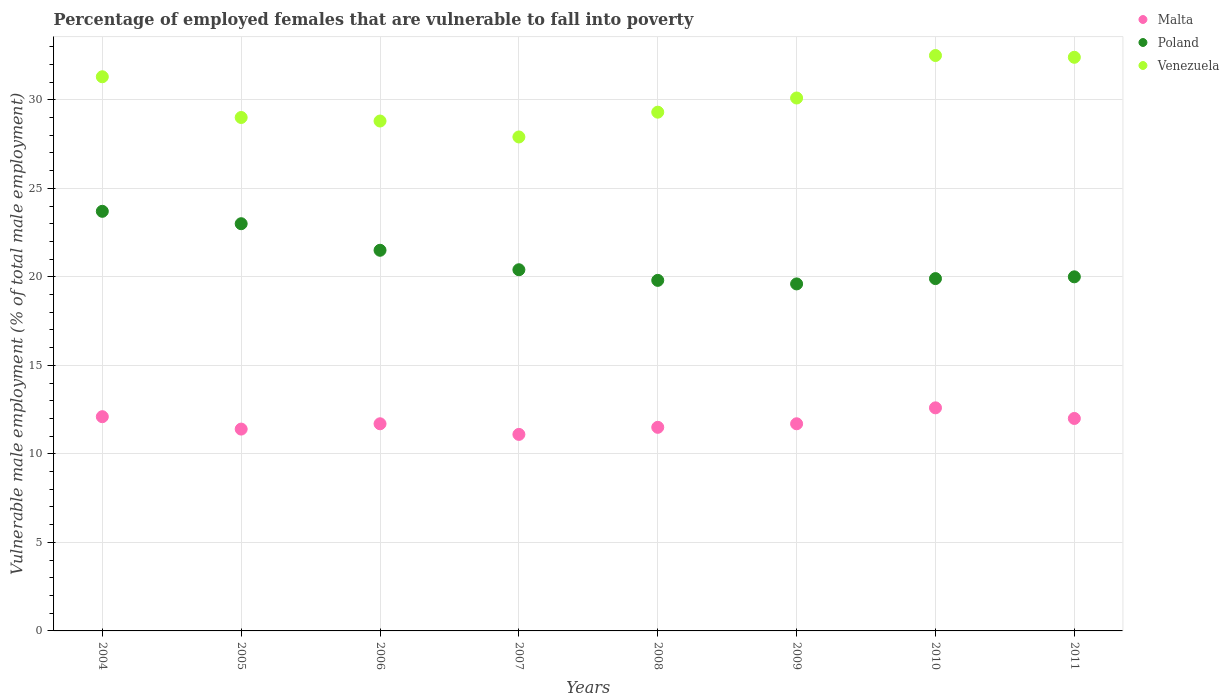Is the number of dotlines equal to the number of legend labels?
Your answer should be compact. Yes. What is the percentage of employed females who are vulnerable to fall into poverty in Venezuela in 2010?
Offer a terse response. 32.5. Across all years, what is the maximum percentage of employed females who are vulnerable to fall into poverty in Poland?
Give a very brief answer. 23.7. Across all years, what is the minimum percentage of employed females who are vulnerable to fall into poverty in Poland?
Offer a terse response. 19.6. In which year was the percentage of employed females who are vulnerable to fall into poverty in Malta maximum?
Provide a succinct answer. 2010. What is the total percentage of employed females who are vulnerable to fall into poverty in Poland in the graph?
Keep it short and to the point. 167.9. What is the difference between the percentage of employed females who are vulnerable to fall into poverty in Venezuela in 2006 and that in 2010?
Offer a terse response. -3.7. What is the difference between the percentage of employed females who are vulnerable to fall into poverty in Poland in 2009 and the percentage of employed females who are vulnerable to fall into poverty in Malta in 2007?
Provide a succinct answer. 8.5. What is the average percentage of employed females who are vulnerable to fall into poverty in Venezuela per year?
Your answer should be very brief. 30.16. In the year 2004, what is the difference between the percentage of employed females who are vulnerable to fall into poverty in Venezuela and percentage of employed females who are vulnerable to fall into poverty in Malta?
Offer a very short reply. 19.2. What is the ratio of the percentage of employed females who are vulnerable to fall into poverty in Poland in 2005 to that in 2007?
Offer a terse response. 1.13. Is the difference between the percentage of employed females who are vulnerable to fall into poverty in Venezuela in 2008 and 2010 greater than the difference between the percentage of employed females who are vulnerable to fall into poverty in Malta in 2008 and 2010?
Provide a short and direct response. No. What is the difference between the highest and the lowest percentage of employed females who are vulnerable to fall into poverty in Poland?
Give a very brief answer. 4.1. Is it the case that in every year, the sum of the percentage of employed females who are vulnerable to fall into poverty in Malta and percentage of employed females who are vulnerable to fall into poverty in Venezuela  is greater than the percentage of employed females who are vulnerable to fall into poverty in Poland?
Ensure brevity in your answer.  Yes. Is the percentage of employed females who are vulnerable to fall into poverty in Malta strictly greater than the percentage of employed females who are vulnerable to fall into poverty in Venezuela over the years?
Provide a short and direct response. No. Is the percentage of employed females who are vulnerable to fall into poverty in Malta strictly less than the percentage of employed females who are vulnerable to fall into poverty in Poland over the years?
Your answer should be very brief. Yes. How many years are there in the graph?
Ensure brevity in your answer.  8. What is the difference between two consecutive major ticks on the Y-axis?
Make the answer very short. 5. Does the graph contain any zero values?
Give a very brief answer. No. What is the title of the graph?
Offer a very short reply. Percentage of employed females that are vulnerable to fall into poverty. What is the label or title of the X-axis?
Offer a very short reply. Years. What is the label or title of the Y-axis?
Provide a short and direct response. Vulnerable male employment (% of total male employment). What is the Vulnerable male employment (% of total male employment) of Malta in 2004?
Provide a succinct answer. 12.1. What is the Vulnerable male employment (% of total male employment) of Poland in 2004?
Provide a short and direct response. 23.7. What is the Vulnerable male employment (% of total male employment) of Venezuela in 2004?
Make the answer very short. 31.3. What is the Vulnerable male employment (% of total male employment) of Malta in 2005?
Provide a succinct answer. 11.4. What is the Vulnerable male employment (% of total male employment) in Malta in 2006?
Ensure brevity in your answer.  11.7. What is the Vulnerable male employment (% of total male employment) of Venezuela in 2006?
Give a very brief answer. 28.8. What is the Vulnerable male employment (% of total male employment) in Malta in 2007?
Make the answer very short. 11.1. What is the Vulnerable male employment (% of total male employment) in Poland in 2007?
Provide a succinct answer. 20.4. What is the Vulnerable male employment (% of total male employment) of Venezuela in 2007?
Your answer should be very brief. 27.9. What is the Vulnerable male employment (% of total male employment) of Poland in 2008?
Your response must be concise. 19.8. What is the Vulnerable male employment (% of total male employment) of Venezuela in 2008?
Keep it short and to the point. 29.3. What is the Vulnerable male employment (% of total male employment) in Malta in 2009?
Your response must be concise. 11.7. What is the Vulnerable male employment (% of total male employment) in Poland in 2009?
Offer a terse response. 19.6. What is the Vulnerable male employment (% of total male employment) in Venezuela in 2009?
Your answer should be compact. 30.1. What is the Vulnerable male employment (% of total male employment) in Malta in 2010?
Your response must be concise. 12.6. What is the Vulnerable male employment (% of total male employment) in Poland in 2010?
Your answer should be very brief. 19.9. What is the Vulnerable male employment (% of total male employment) of Venezuela in 2010?
Ensure brevity in your answer.  32.5. What is the Vulnerable male employment (% of total male employment) in Poland in 2011?
Make the answer very short. 20. What is the Vulnerable male employment (% of total male employment) in Venezuela in 2011?
Ensure brevity in your answer.  32.4. Across all years, what is the maximum Vulnerable male employment (% of total male employment) in Malta?
Your answer should be compact. 12.6. Across all years, what is the maximum Vulnerable male employment (% of total male employment) of Poland?
Offer a terse response. 23.7. Across all years, what is the maximum Vulnerable male employment (% of total male employment) of Venezuela?
Offer a terse response. 32.5. Across all years, what is the minimum Vulnerable male employment (% of total male employment) in Malta?
Offer a terse response. 11.1. Across all years, what is the minimum Vulnerable male employment (% of total male employment) of Poland?
Provide a short and direct response. 19.6. Across all years, what is the minimum Vulnerable male employment (% of total male employment) in Venezuela?
Your response must be concise. 27.9. What is the total Vulnerable male employment (% of total male employment) of Malta in the graph?
Make the answer very short. 94.1. What is the total Vulnerable male employment (% of total male employment) in Poland in the graph?
Give a very brief answer. 167.9. What is the total Vulnerable male employment (% of total male employment) of Venezuela in the graph?
Your answer should be very brief. 241.3. What is the difference between the Vulnerable male employment (% of total male employment) of Malta in 2004 and that in 2005?
Offer a terse response. 0.7. What is the difference between the Vulnerable male employment (% of total male employment) of Poland in 2004 and that in 2006?
Ensure brevity in your answer.  2.2. What is the difference between the Vulnerable male employment (% of total male employment) in Venezuela in 2004 and that in 2006?
Ensure brevity in your answer.  2.5. What is the difference between the Vulnerable male employment (% of total male employment) of Poland in 2004 and that in 2007?
Make the answer very short. 3.3. What is the difference between the Vulnerable male employment (% of total male employment) in Malta in 2004 and that in 2009?
Offer a terse response. 0.4. What is the difference between the Vulnerable male employment (% of total male employment) of Poland in 2004 and that in 2009?
Your answer should be compact. 4.1. What is the difference between the Vulnerable male employment (% of total male employment) in Malta in 2004 and that in 2010?
Offer a terse response. -0.5. What is the difference between the Vulnerable male employment (% of total male employment) of Malta in 2004 and that in 2011?
Make the answer very short. 0.1. What is the difference between the Vulnerable male employment (% of total male employment) in Poland in 2004 and that in 2011?
Ensure brevity in your answer.  3.7. What is the difference between the Vulnerable male employment (% of total male employment) in Malta in 2005 and that in 2006?
Your answer should be compact. -0.3. What is the difference between the Vulnerable male employment (% of total male employment) of Venezuela in 2005 and that in 2006?
Make the answer very short. 0.2. What is the difference between the Vulnerable male employment (% of total male employment) in Venezuela in 2005 and that in 2007?
Keep it short and to the point. 1.1. What is the difference between the Vulnerable male employment (% of total male employment) in Poland in 2005 and that in 2008?
Provide a short and direct response. 3.2. What is the difference between the Vulnerable male employment (% of total male employment) in Malta in 2005 and that in 2009?
Give a very brief answer. -0.3. What is the difference between the Vulnerable male employment (% of total male employment) of Poland in 2005 and that in 2009?
Your answer should be very brief. 3.4. What is the difference between the Vulnerable male employment (% of total male employment) in Venezuela in 2005 and that in 2009?
Give a very brief answer. -1.1. What is the difference between the Vulnerable male employment (% of total male employment) in Malta in 2005 and that in 2011?
Offer a terse response. -0.6. What is the difference between the Vulnerable male employment (% of total male employment) in Poland in 2005 and that in 2011?
Provide a succinct answer. 3. What is the difference between the Vulnerable male employment (% of total male employment) of Venezuela in 2005 and that in 2011?
Your response must be concise. -3.4. What is the difference between the Vulnerable male employment (% of total male employment) in Poland in 2006 and that in 2007?
Offer a terse response. 1.1. What is the difference between the Vulnerable male employment (% of total male employment) in Malta in 2006 and that in 2008?
Provide a short and direct response. 0.2. What is the difference between the Vulnerable male employment (% of total male employment) in Malta in 2006 and that in 2009?
Your response must be concise. 0. What is the difference between the Vulnerable male employment (% of total male employment) of Poland in 2006 and that in 2010?
Ensure brevity in your answer.  1.6. What is the difference between the Vulnerable male employment (% of total male employment) of Venezuela in 2006 and that in 2010?
Your answer should be very brief. -3.7. What is the difference between the Vulnerable male employment (% of total male employment) in Malta in 2006 and that in 2011?
Make the answer very short. -0.3. What is the difference between the Vulnerable male employment (% of total male employment) of Poland in 2006 and that in 2011?
Provide a succinct answer. 1.5. What is the difference between the Vulnerable male employment (% of total male employment) in Venezuela in 2006 and that in 2011?
Your answer should be very brief. -3.6. What is the difference between the Vulnerable male employment (% of total male employment) in Poland in 2007 and that in 2008?
Offer a terse response. 0.6. What is the difference between the Vulnerable male employment (% of total male employment) in Venezuela in 2007 and that in 2008?
Keep it short and to the point. -1.4. What is the difference between the Vulnerable male employment (% of total male employment) of Venezuela in 2007 and that in 2009?
Your answer should be compact. -2.2. What is the difference between the Vulnerable male employment (% of total male employment) in Malta in 2007 and that in 2010?
Provide a short and direct response. -1.5. What is the difference between the Vulnerable male employment (% of total male employment) in Malta in 2007 and that in 2011?
Make the answer very short. -0.9. What is the difference between the Vulnerable male employment (% of total male employment) in Poland in 2007 and that in 2011?
Ensure brevity in your answer.  0.4. What is the difference between the Vulnerable male employment (% of total male employment) of Venezuela in 2007 and that in 2011?
Ensure brevity in your answer.  -4.5. What is the difference between the Vulnerable male employment (% of total male employment) in Malta in 2008 and that in 2009?
Keep it short and to the point. -0.2. What is the difference between the Vulnerable male employment (% of total male employment) of Poland in 2008 and that in 2009?
Your answer should be compact. 0.2. What is the difference between the Vulnerable male employment (% of total male employment) in Malta in 2008 and that in 2010?
Your answer should be compact. -1.1. What is the difference between the Vulnerable male employment (% of total male employment) in Poland in 2008 and that in 2010?
Give a very brief answer. -0.1. What is the difference between the Vulnerable male employment (% of total male employment) of Venezuela in 2008 and that in 2010?
Offer a very short reply. -3.2. What is the difference between the Vulnerable male employment (% of total male employment) in Malta in 2008 and that in 2011?
Your answer should be very brief. -0.5. What is the difference between the Vulnerable male employment (% of total male employment) of Venezuela in 2008 and that in 2011?
Your answer should be compact. -3.1. What is the difference between the Vulnerable male employment (% of total male employment) in Malta in 2009 and that in 2010?
Ensure brevity in your answer.  -0.9. What is the difference between the Vulnerable male employment (% of total male employment) in Malta in 2009 and that in 2011?
Make the answer very short. -0.3. What is the difference between the Vulnerable male employment (% of total male employment) of Poland in 2009 and that in 2011?
Provide a succinct answer. -0.4. What is the difference between the Vulnerable male employment (% of total male employment) of Venezuela in 2009 and that in 2011?
Your answer should be compact. -2.3. What is the difference between the Vulnerable male employment (% of total male employment) of Poland in 2010 and that in 2011?
Make the answer very short. -0.1. What is the difference between the Vulnerable male employment (% of total male employment) in Malta in 2004 and the Vulnerable male employment (% of total male employment) in Venezuela in 2005?
Keep it short and to the point. -16.9. What is the difference between the Vulnerable male employment (% of total male employment) in Poland in 2004 and the Vulnerable male employment (% of total male employment) in Venezuela in 2005?
Keep it short and to the point. -5.3. What is the difference between the Vulnerable male employment (% of total male employment) in Malta in 2004 and the Vulnerable male employment (% of total male employment) in Venezuela in 2006?
Your answer should be compact. -16.7. What is the difference between the Vulnerable male employment (% of total male employment) in Poland in 2004 and the Vulnerable male employment (% of total male employment) in Venezuela in 2006?
Your answer should be compact. -5.1. What is the difference between the Vulnerable male employment (% of total male employment) in Malta in 2004 and the Vulnerable male employment (% of total male employment) in Venezuela in 2007?
Offer a very short reply. -15.8. What is the difference between the Vulnerable male employment (% of total male employment) of Malta in 2004 and the Vulnerable male employment (% of total male employment) of Venezuela in 2008?
Provide a short and direct response. -17.2. What is the difference between the Vulnerable male employment (% of total male employment) of Poland in 2004 and the Vulnerable male employment (% of total male employment) of Venezuela in 2008?
Keep it short and to the point. -5.6. What is the difference between the Vulnerable male employment (% of total male employment) of Malta in 2004 and the Vulnerable male employment (% of total male employment) of Poland in 2009?
Provide a short and direct response. -7.5. What is the difference between the Vulnerable male employment (% of total male employment) of Malta in 2004 and the Vulnerable male employment (% of total male employment) of Venezuela in 2009?
Offer a very short reply. -18. What is the difference between the Vulnerable male employment (% of total male employment) in Malta in 2004 and the Vulnerable male employment (% of total male employment) in Poland in 2010?
Your answer should be compact. -7.8. What is the difference between the Vulnerable male employment (% of total male employment) of Malta in 2004 and the Vulnerable male employment (% of total male employment) of Venezuela in 2010?
Make the answer very short. -20.4. What is the difference between the Vulnerable male employment (% of total male employment) of Poland in 2004 and the Vulnerable male employment (% of total male employment) of Venezuela in 2010?
Ensure brevity in your answer.  -8.8. What is the difference between the Vulnerable male employment (% of total male employment) in Malta in 2004 and the Vulnerable male employment (% of total male employment) in Poland in 2011?
Ensure brevity in your answer.  -7.9. What is the difference between the Vulnerable male employment (% of total male employment) in Malta in 2004 and the Vulnerable male employment (% of total male employment) in Venezuela in 2011?
Provide a succinct answer. -20.3. What is the difference between the Vulnerable male employment (% of total male employment) in Poland in 2004 and the Vulnerable male employment (% of total male employment) in Venezuela in 2011?
Give a very brief answer. -8.7. What is the difference between the Vulnerable male employment (% of total male employment) in Malta in 2005 and the Vulnerable male employment (% of total male employment) in Venezuela in 2006?
Keep it short and to the point. -17.4. What is the difference between the Vulnerable male employment (% of total male employment) of Poland in 2005 and the Vulnerable male employment (% of total male employment) of Venezuela in 2006?
Provide a succinct answer. -5.8. What is the difference between the Vulnerable male employment (% of total male employment) in Malta in 2005 and the Vulnerable male employment (% of total male employment) in Venezuela in 2007?
Provide a short and direct response. -16.5. What is the difference between the Vulnerable male employment (% of total male employment) of Malta in 2005 and the Vulnerable male employment (% of total male employment) of Venezuela in 2008?
Your answer should be very brief. -17.9. What is the difference between the Vulnerable male employment (% of total male employment) in Poland in 2005 and the Vulnerable male employment (% of total male employment) in Venezuela in 2008?
Your response must be concise. -6.3. What is the difference between the Vulnerable male employment (% of total male employment) in Malta in 2005 and the Vulnerable male employment (% of total male employment) in Venezuela in 2009?
Offer a very short reply. -18.7. What is the difference between the Vulnerable male employment (% of total male employment) in Poland in 2005 and the Vulnerable male employment (% of total male employment) in Venezuela in 2009?
Offer a very short reply. -7.1. What is the difference between the Vulnerable male employment (% of total male employment) of Malta in 2005 and the Vulnerable male employment (% of total male employment) of Poland in 2010?
Your answer should be compact. -8.5. What is the difference between the Vulnerable male employment (% of total male employment) of Malta in 2005 and the Vulnerable male employment (% of total male employment) of Venezuela in 2010?
Provide a short and direct response. -21.1. What is the difference between the Vulnerable male employment (% of total male employment) in Poland in 2005 and the Vulnerable male employment (% of total male employment) in Venezuela in 2010?
Your answer should be very brief. -9.5. What is the difference between the Vulnerable male employment (% of total male employment) in Malta in 2005 and the Vulnerable male employment (% of total male employment) in Venezuela in 2011?
Provide a short and direct response. -21. What is the difference between the Vulnerable male employment (% of total male employment) of Malta in 2006 and the Vulnerable male employment (% of total male employment) of Venezuela in 2007?
Offer a terse response. -16.2. What is the difference between the Vulnerable male employment (% of total male employment) in Malta in 2006 and the Vulnerable male employment (% of total male employment) in Poland in 2008?
Provide a short and direct response. -8.1. What is the difference between the Vulnerable male employment (% of total male employment) in Malta in 2006 and the Vulnerable male employment (% of total male employment) in Venezuela in 2008?
Ensure brevity in your answer.  -17.6. What is the difference between the Vulnerable male employment (% of total male employment) of Malta in 2006 and the Vulnerable male employment (% of total male employment) of Poland in 2009?
Provide a short and direct response. -7.9. What is the difference between the Vulnerable male employment (% of total male employment) in Malta in 2006 and the Vulnerable male employment (% of total male employment) in Venezuela in 2009?
Ensure brevity in your answer.  -18.4. What is the difference between the Vulnerable male employment (% of total male employment) of Poland in 2006 and the Vulnerable male employment (% of total male employment) of Venezuela in 2009?
Ensure brevity in your answer.  -8.6. What is the difference between the Vulnerable male employment (% of total male employment) of Malta in 2006 and the Vulnerable male employment (% of total male employment) of Poland in 2010?
Make the answer very short. -8.2. What is the difference between the Vulnerable male employment (% of total male employment) in Malta in 2006 and the Vulnerable male employment (% of total male employment) in Venezuela in 2010?
Ensure brevity in your answer.  -20.8. What is the difference between the Vulnerable male employment (% of total male employment) of Poland in 2006 and the Vulnerable male employment (% of total male employment) of Venezuela in 2010?
Your response must be concise. -11. What is the difference between the Vulnerable male employment (% of total male employment) in Malta in 2006 and the Vulnerable male employment (% of total male employment) in Venezuela in 2011?
Your answer should be compact. -20.7. What is the difference between the Vulnerable male employment (% of total male employment) in Poland in 2006 and the Vulnerable male employment (% of total male employment) in Venezuela in 2011?
Offer a very short reply. -10.9. What is the difference between the Vulnerable male employment (% of total male employment) of Malta in 2007 and the Vulnerable male employment (% of total male employment) of Venezuela in 2008?
Give a very brief answer. -18.2. What is the difference between the Vulnerable male employment (% of total male employment) of Malta in 2007 and the Vulnerable male employment (% of total male employment) of Poland in 2009?
Ensure brevity in your answer.  -8.5. What is the difference between the Vulnerable male employment (% of total male employment) of Malta in 2007 and the Vulnerable male employment (% of total male employment) of Poland in 2010?
Your response must be concise. -8.8. What is the difference between the Vulnerable male employment (% of total male employment) in Malta in 2007 and the Vulnerable male employment (% of total male employment) in Venezuela in 2010?
Make the answer very short. -21.4. What is the difference between the Vulnerable male employment (% of total male employment) in Malta in 2007 and the Vulnerable male employment (% of total male employment) in Venezuela in 2011?
Make the answer very short. -21.3. What is the difference between the Vulnerable male employment (% of total male employment) of Malta in 2008 and the Vulnerable male employment (% of total male employment) of Venezuela in 2009?
Your answer should be very brief. -18.6. What is the difference between the Vulnerable male employment (% of total male employment) of Malta in 2008 and the Vulnerable male employment (% of total male employment) of Venezuela in 2010?
Your answer should be compact. -21. What is the difference between the Vulnerable male employment (% of total male employment) of Poland in 2008 and the Vulnerable male employment (% of total male employment) of Venezuela in 2010?
Ensure brevity in your answer.  -12.7. What is the difference between the Vulnerable male employment (% of total male employment) of Malta in 2008 and the Vulnerable male employment (% of total male employment) of Venezuela in 2011?
Provide a succinct answer. -20.9. What is the difference between the Vulnerable male employment (% of total male employment) in Malta in 2009 and the Vulnerable male employment (% of total male employment) in Poland in 2010?
Give a very brief answer. -8.2. What is the difference between the Vulnerable male employment (% of total male employment) in Malta in 2009 and the Vulnerable male employment (% of total male employment) in Venezuela in 2010?
Give a very brief answer. -20.8. What is the difference between the Vulnerable male employment (% of total male employment) in Poland in 2009 and the Vulnerable male employment (% of total male employment) in Venezuela in 2010?
Ensure brevity in your answer.  -12.9. What is the difference between the Vulnerable male employment (% of total male employment) in Malta in 2009 and the Vulnerable male employment (% of total male employment) in Venezuela in 2011?
Provide a short and direct response. -20.7. What is the difference between the Vulnerable male employment (% of total male employment) in Poland in 2009 and the Vulnerable male employment (% of total male employment) in Venezuela in 2011?
Offer a very short reply. -12.8. What is the difference between the Vulnerable male employment (% of total male employment) of Malta in 2010 and the Vulnerable male employment (% of total male employment) of Poland in 2011?
Ensure brevity in your answer.  -7.4. What is the difference between the Vulnerable male employment (% of total male employment) in Malta in 2010 and the Vulnerable male employment (% of total male employment) in Venezuela in 2011?
Provide a succinct answer. -19.8. What is the difference between the Vulnerable male employment (% of total male employment) in Poland in 2010 and the Vulnerable male employment (% of total male employment) in Venezuela in 2011?
Ensure brevity in your answer.  -12.5. What is the average Vulnerable male employment (% of total male employment) of Malta per year?
Offer a very short reply. 11.76. What is the average Vulnerable male employment (% of total male employment) of Poland per year?
Ensure brevity in your answer.  20.99. What is the average Vulnerable male employment (% of total male employment) of Venezuela per year?
Give a very brief answer. 30.16. In the year 2004, what is the difference between the Vulnerable male employment (% of total male employment) in Malta and Vulnerable male employment (% of total male employment) in Poland?
Ensure brevity in your answer.  -11.6. In the year 2004, what is the difference between the Vulnerable male employment (% of total male employment) in Malta and Vulnerable male employment (% of total male employment) in Venezuela?
Provide a short and direct response. -19.2. In the year 2005, what is the difference between the Vulnerable male employment (% of total male employment) in Malta and Vulnerable male employment (% of total male employment) in Venezuela?
Give a very brief answer. -17.6. In the year 2006, what is the difference between the Vulnerable male employment (% of total male employment) of Malta and Vulnerable male employment (% of total male employment) of Poland?
Your answer should be compact. -9.8. In the year 2006, what is the difference between the Vulnerable male employment (% of total male employment) of Malta and Vulnerable male employment (% of total male employment) of Venezuela?
Offer a terse response. -17.1. In the year 2007, what is the difference between the Vulnerable male employment (% of total male employment) in Malta and Vulnerable male employment (% of total male employment) in Poland?
Your answer should be very brief. -9.3. In the year 2007, what is the difference between the Vulnerable male employment (% of total male employment) of Malta and Vulnerable male employment (% of total male employment) of Venezuela?
Provide a short and direct response. -16.8. In the year 2008, what is the difference between the Vulnerable male employment (% of total male employment) in Malta and Vulnerable male employment (% of total male employment) in Poland?
Make the answer very short. -8.3. In the year 2008, what is the difference between the Vulnerable male employment (% of total male employment) in Malta and Vulnerable male employment (% of total male employment) in Venezuela?
Ensure brevity in your answer.  -17.8. In the year 2008, what is the difference between the Vulnerable male employment (% of total male employment) in Poland and Vulnerable male employment (% of total male employment) in Venezuela?
Keep it short and to the point. -9.5. In the year 2009, what is the difference between the Vulnerable male employment (% of total male employment) in Malta and Vulnerable male employment (% of total male employment) in Poland?
Offer a very short reply. -7.9. In the year 2009, what is the difference between the Vulnerable male employment (% of total male employment) in Malta and Vulnerable male employment (% of total male employment) in Venezuela?
Give a very brief answer. -18.4. In the year 2010, what is the difference between the Vulnerable male employment (% of total male employment) of Malta and Vulnerable male employment (% of total male employment) of Venezuela?
Provide a succinct answer. -19.9. In the year 2011, what is the difference between the Vulnerable male employment (% of total male employment) in Malta and Vulnerable male employment (% of total male employment) in Poland?
Give a very brief answer. -8. In the year 2011, what is the difference between the Vulnerable male employment (% of total male employment) of Malta and Vulnerable male employment (% of total male employment) of Venezuela?
Your answer should be very brief. -20.4. What is the ratio of the Vulnerable male employment (% of total male employment) of Malta in 2004 to that in 2005?
Make the answer very short. 1.06. What is the ratio of the Vulnerable male employment (% of total male employment) in Poland in 2004 to that in 2005?
Your response must be concise. 1.03. What is the ratio of the Vulnerable male employment (% of total male employment) in Venezuela in 2004 to that in 2005?
Give a very brief answer. 1.08. What is the ratio of the Vulnerable male employment (% of total male employment) in Malta in 2004 to that in 2006?
Offer a terse response. 1.03. What is the ratio of the Vulnerable male employment (% of total male employment) in Poland in 2004 to that in 2006?
Give a very brief answer. 1.1. What is the ratio of the Vulnerable male employment (% of total male employment) in Venezuela in 2004 to that in 2006?
Your response must be concise. 1.09. What is the ratio of the Vulnerable male employment (% of total male employment) of Malta in 2004 to that in 2007?
Make the answer very short. 1.09. What is the ratio of the Vulnerable male employment (% of total male employment) in Poland in 2004 to that in 2007?
Your response must be concise. 1.16. What is the ratio of the Vulnerable male employment (% of total male employment) in Venezuela in 2004 to that in 2007?
Offer a very short reply. 1.12. What is the ratio of the Vulnerable male employment (% of total male employment) in Malta in 2004 to that in 2008?
Provide a short and direct response. 1.05. What is the ratio of the Vulnerable male employment (% of total male employment) of Poland in 2004 to that in 2008?
Provide a short and direct response. 1.2. What is the ratio of the Vulnerable male employment (% of total male employment) of Venezuela in 2004 to that in 2008?
Offer a terse response. 1.07. What is the ratio of the Vulnerable male employment (% of total male employment) of Malta in 2004 to that in 2009?
Ensure brevity in your answer.  1.03. What is the ratio of the Vulnerable male employment (% of total male employment) in Poland in 2004 to that in 2009?
Provide a succinct answer. 1.21. What is the ratio of the Vulnerable male employment (% of total male employment) of Venezuela in 2004 to that in 2009?
Your answer should be compact. 1.04. What is the ratio of the Vulnerable male employment (% of total male employment) of Malta in 2004 to that in 2010?
Your response must be concise. 0.96. What is the ratio of the Vulnerable male employment (% of total male employment) of Poland in 2004 to that in 2010?
Your answer should be compact. 1.19. What is the ratio of the Vulnerable male employment (% of total male employment) of Venezuela in 2004 to that in 2010?
Your answer should be very brief. 0.96. What is the ratio of the Vulnerable male employment (% of total male employment) in Malta in 2004 to that in 2011?
Your response must be concise. 1.01. What is the ratio of the Vulnerable male employment (% of total male employment) of Poland in 2004 to that in 2011?
Offer a very short reply. 1.19. What is the ratio of the Vulnerable male employment (% of total male employment) in Venezuela in 2004 to that in 2011?
Keep it short and to the point. 0.97. What is the ratio of the Vulnerable male employment (% of total male employment) of Malta in 2005 to that in 2006?
Provide a short and direct response. 0.97. What is the ratio of the Vulnerable male employment (% of total male employment) in Poland in 2005 to that in 2006?
Make the answer very short. 1.07. What is the ratio of the Vulnerable male employment (% of total male employment) in Poland in 2005 to that in 2007?
Make the answer very short. 1.13. What is the ratio of the Vulnerable male employment (% of total male employment) in Venezuela in 2005 to that in 2007?
Offer a very short reply. 1.04. What is the ratio of the Vulnerable male employment (% of total male employment) in Malta in 2005 to that in 2008?
Your answer should be compact. 0.99. What is the ratio of the Vulnerable male employment (% of total male employment) of Poland in 2005 to that in 2008?
Provide a succinct answer. 1.16. What is the ratio of the Vulnerable male employment (% of total male employment) in Venezuela in 2005 to that in 2008?
Your answer should be compact. 0.99. What is the ratio of the Vulnerable male employment (% of total male employment) in Malta in 2005 to that in 2009?
Make the answer very short. 0.97. What is the ratio of the Vulnerable male employment (% of total male employment) in Poland in 2005 to that in 2009?
Provide a succinct answer. 1.17. What is the ratio of the Vulnerable male employment (% of total male employment) of Venezuela in 2005 to that in 2009?
Ensure brevity in your answer.  0.96. What is the ratio of the Vulnerable male employment (% of total male employment) in Malta in 2005 to that in 2010?
Provide a succinct answer. 0.9. What is the ratio of the Vulnerable male employment (% of total male employment) in Poland in 2005 to that in 2010?
Your answer should be compact. 1.16. What is the ratio of the Vulnerable male employment (% of total male employment) of Venezuela in 2005 to that in 2010?
Your answer should be compact. 0.89. What is the ratio of the Vulnerable male employment (% of total male employment) in Malta in 2005 to that in 2011?
Your answer should be compact. 0.95. What is the ratio of the Vulnerable male employment (% of total male employment) in Poland in 2005 to that in 2011?
Your response must be concise. 1.15. What is the ratio of the Vulnerable male employment (% of total male employment) in Venezuela in 2005 to that in 2011?
Your answer should be very brief. 0.9. What is the ratio of the Vulnerable male employment (% of total male employment) of Malta in 2006 to that in 2007?
Make the answer very short. 1.05. What is the ratio of the Vulnerable male employment (% of total male employment) of Poland in 2006 to that in 2007?
Ensure brevity in your answer.  1.05. What is the ratio of the Vulnerable male employment (% of total male employment) in Venezuela in 2006 to that in 2007?
Provide a succinct answer. 1.03. What is the ratio of the Vulnerable male employment (% of total male employment) of Malta in 2006 to that in 2008?
Your answer should be very brief. 1.02. What is the ratio of the Vulnerable male employment (% of total male employment) of Poland in 2006 to that in 2008?
Your answer should be compact. 1.09. What is the ratio of the Vulnerable male employment (% of total male employment) of Venezuela in 2006 to that in 2008?
Your answer should be very brief. 0.98. What is the ratio of the Vulnerable male employment (% of total male employment) of Malta in 2006 to that in 2009?
Ensure brevity in your answer.  1. What is the ratio of the Vulnerable male employment (% of total male employment) of Poland in 2006 to that in 2009?
Provide a succinct answer. 1.1. What is the ratio of the Vulnerable male employment (% of total male employment) of Venezuela in 2006 to that in 2009?
Your response must be concise. 0.96. What is the ratio of the Vulnerable male employment (% of total male employment) of Malta in 2006 to that in 2010?
Provide a succinct answer. 0.93. What is the ratio of the Vulnerable male employment (% of total male employment) in Poland in 2006 to that in 2010?
Make the answer very short. 1.08. What is the ratio of the Vulnerable male employment (% of total male employment) of Venezuela in 2006 to that in 2010?
Provide a succinct answer. 0.89. What is the ratio of the Vulnerable male employment (% of total male employment) in Malta in 2006 to that in 2011?
Your answer should be very brief. 0.97. What is the ratio of the Vulnerable male employment (% of total male employment) of Poland in 2006 to that in 2011?
Offer a terse response. 1.07. What is the ratio of the Vulnerable male employment (% of total male employment) of Malta in 2007 to that in 2008?
Offer a terse response. 0.97. What is the ratio of the Vulnerable male employment (% of total male employment) of Poland in 2007 to that in 2008?
Ensure brevity in your answer.  1.03. What is the ratio of the Vulnerable male employment (% of total male employment) of Venezuela in 2007 to that in 2008?
Make the answer very short. 0.95. What is the ratio of the Vulnerable male employment (% of total male employment) in Malta in 2007 to that in 2009?
Your answer should be very brief. 0.95. What is the ratio of the Vulnerable male employment (% of total male employment) of Poland in 2007 to that in 2009?
Provide a succinct answer. 1.04. What is the ratio of the Vulnerable male employment (% of total male employment) of Venezuela in 2007 to that in 2009?
Provide a short and direct response. 0.93. What is the ratio of the Vulnerable male employment (% of total male employment) of Malta in 2007 to that in 2010?
Offer a terse response. 0.88. What is the ratio of the Vulnerable male employment (% of total male employment) of Poland in 2007 to that in 2010?
Offer a terse response. 1.03. What is the ratio of the Vulnerable male employment (% of total male employment) of Venezuela in 2007 to that in 2010?
Your answer should be very brief. 0.86. What is the ratio of the Vulnerable male employment (% of total male employment) in Malta in 2007 to that in 2011?
Give a very brief answer. 0.93. What is the ratio of the Vulnerable male employment (% of total male employment) in Venezuela in 2007 to that in 2011?
Offer a terse response. 0.86. What is the ratio of the Vulnerable male employment (% of total male employment) of Malta in 2008 to that in 2009?
Offer a terse response. 0.98. What is the ratio of the Vulnerable male employment (% of total male employment) in Poland in 2008 to that in 2009?
Your response must be concise. 1.01. What is the ratio of the Vulnerable male employment (% of total male employment) of Venezuela in 2008 to that in 2009?
Your answer should be compact. 0.97. What is the ratio of the Vulnerable male employment (% of total male employment) of Malta in 2008 to that in 2010?
Keep it short and to the point. 0.91. What is the ratio of the Vulnerable male employment (% of total male employment) in Poland in 2008 to that in 2010?
Offer a very short reply. 0.99. What is the ratio of the Vulnerable male employment (% of total male employment) in Venezuela in 2008 to that in 2010?
Offer a terse response. 0.9. What is the ratio of the Vulnerable male employment (% of total male employment) of Malta in 2008 to that in 2011?
Offer a very short reply. 0.96. What is the ratio of the Vulnerable male employment (% of total male employment) of Venezuela in 2008 to that in 2011?
Your answer should be very brief. 0.9. What is the ratio of the Vulnerable male employment (% of total male employment) in Poland in 2009 to that in 2010?
Provide a succinct answer. 0.98. What is the ratio of the Vulnerable male employment (% of total male employment) in Venezuela in 2009 to that in 2010?
Keep it short and to the point. 0.93. What is the ratio of the Vulnerable male employment (% of total male employment) in Poland in 2009 to that in 2011?
Make the answer very short. 0.98. What is the ratio of the Vulnerable male employment (% of total male employment) of Venezuela in 2009 to that in 2011?
Your answer should be very brief. 0.93. What is the ratio of the Vulnerable male employment (% of total male employment) of Poland in 2010 to that in 2011?
Offer a terse response. 0.99. What is the ratio of the Vulnerable male employment (% of total male employment) of Venezuela in 2010 to that in 2011?
Offer a very short reply. 1. What is the difference between the highest and the lowest Vulnerable male employment (% of total male employment) of Malta?
Provide a succinct answer. 1.5. 